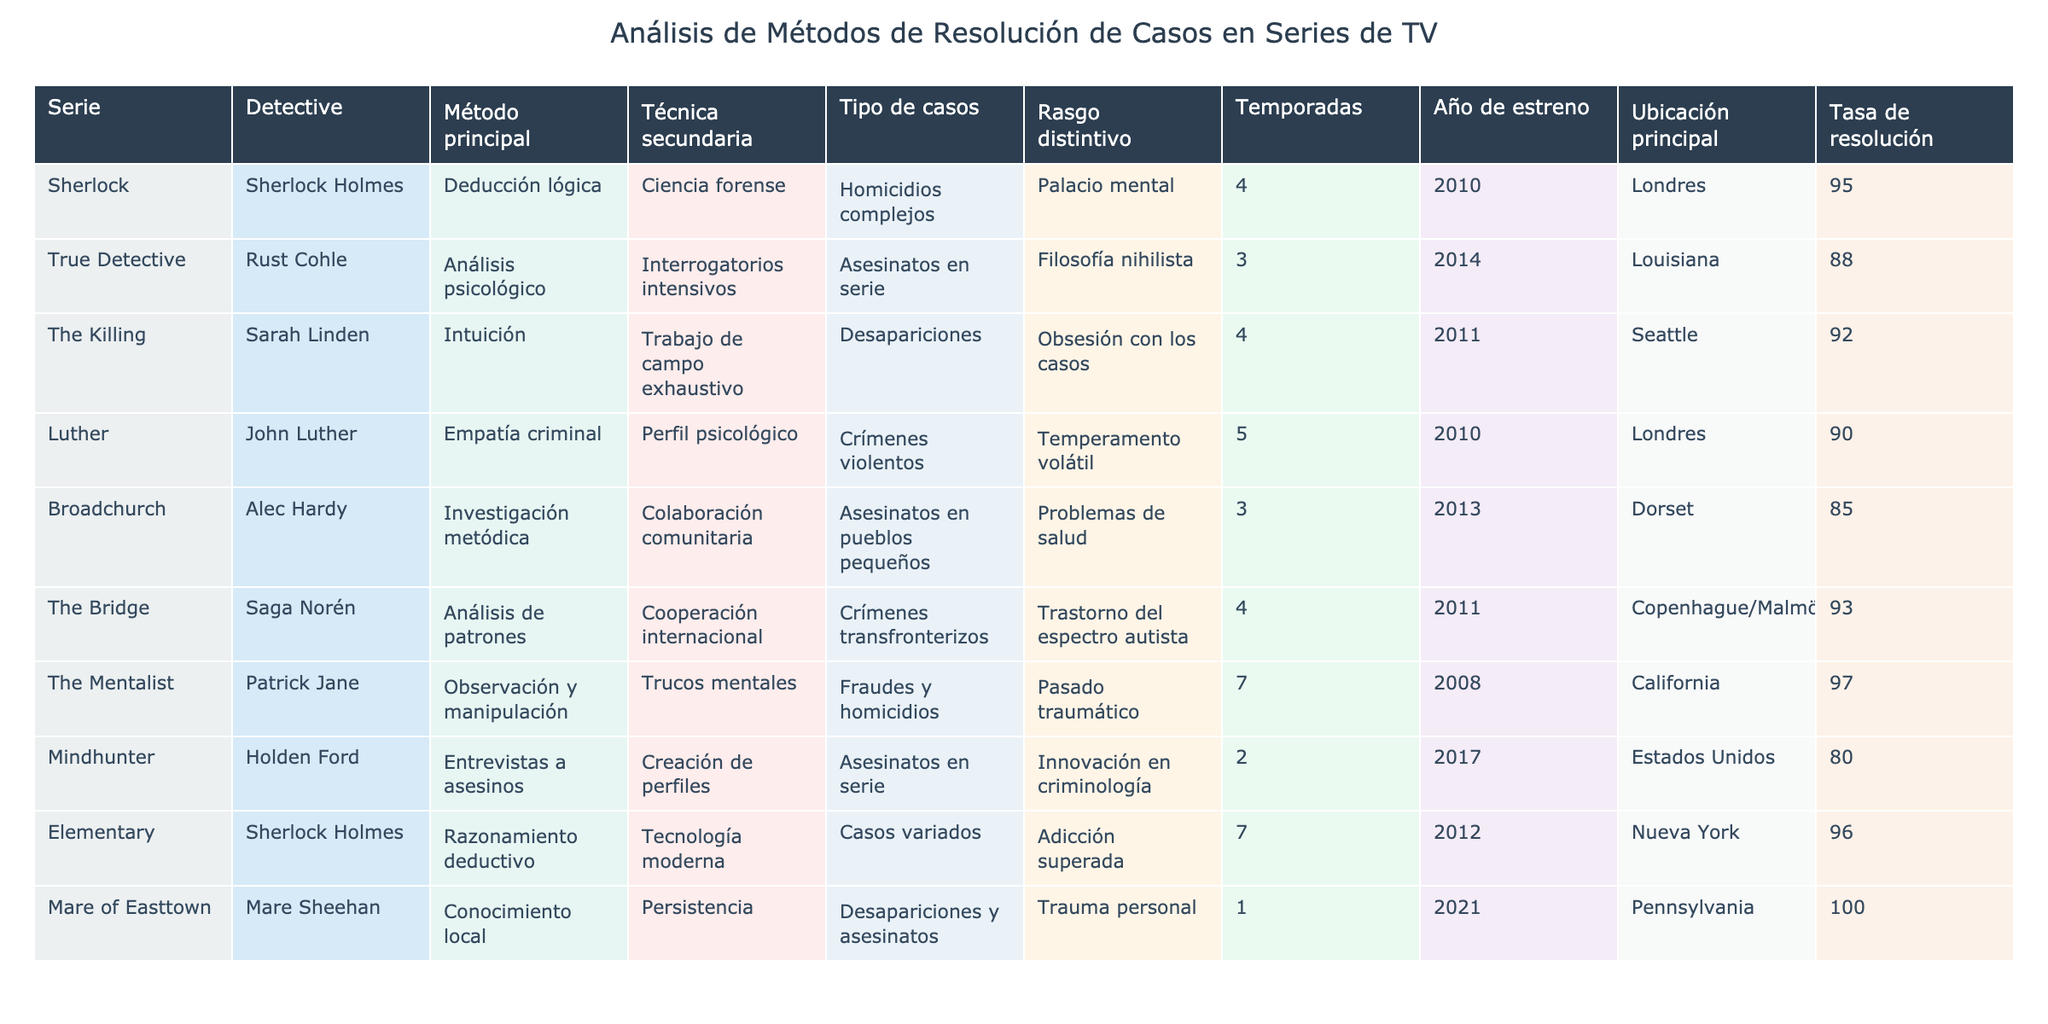¿Cuál es el detective con la tasa de resolución más alta? Al observar la columna de la tasa de resolución, Mare Sheehan tiene la tasa más alta de 100%.
Answer: Mare Sheehan ¿Qué técnica secundaria utiliza Sherlock Holmes? La técnica secundaria que utiliza Sherlock Holmes es la tecnología moderna.
Answer: Tecnología moderna ¿Cuántas temporadas tiene The Mentalist? La tabla muestra que The Mentalist tiene 7 temporadas.
Answer: 7 ¿Cuál es el año de estreno de Broadchurch? De acuerdo a la tabla, Broadchurch se estrenó en el año 2013.
Answer: 2013 ¿Hay algún detective que utilice tanto el análisis psicológico como la cooperación internacional? No, al observar la tabla, ningún detective utiliza ambos métodos simultáneamente.
Answer: No ¿Qué tipo de casos investiga Alec Hardy? Según la tabla, Alec Hardy investiga asesinatos en pueblos pequeños.
Answer: Asesinatos en pueblos pequeños ¿Cuál es el promedio de la tasa de resolución de todos los detectives? Sumando las tasas (95 + 88 + 92 + 90 + 85 + 93 + 97 + 80 + 96 + 100) = 916 y dividiendo por 10 detectives se obtiene 916 / 10 = 91.6%.
Answer: 91.6% ¿Luther y Sherlock Holmes comparten alguna técnica secundaria similar? No, Luther utiliza perfil psicológico y Sherlock Holmes usa ciencia forense, lo que indica que no comparten la misma técnica secundaria.
Answer: No ¿Cuántos detectives trabajan en Londres? Los detectives que trabajan en Londres son Sherlock Holmes y John Luther, por lo que hay 2.
Answer: 2 ¿Es verdadero que el distrito donde trabaja Sarah Linden tiene una tasa de resolución superior al 90%? Sí, Sarah Linden tiene una tasa de resolución del 92%, que es superior al 90%.
Answer: Sí 